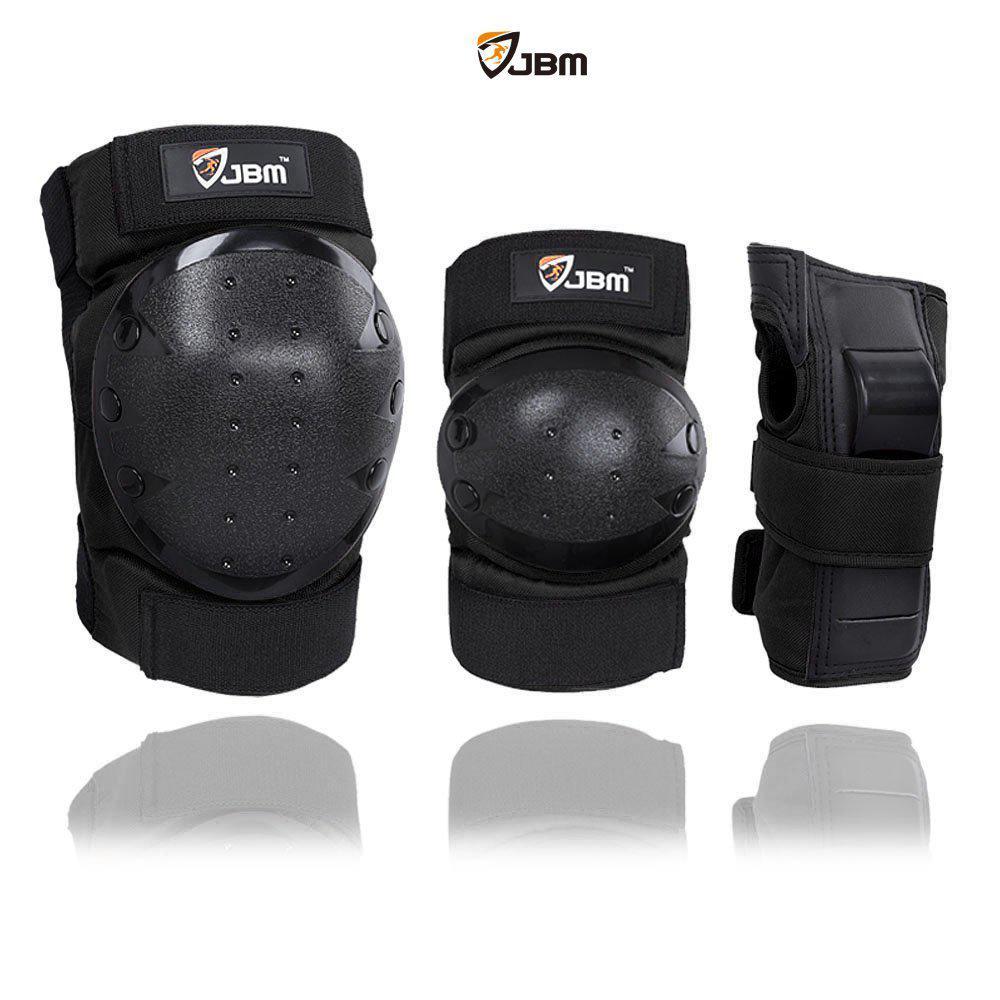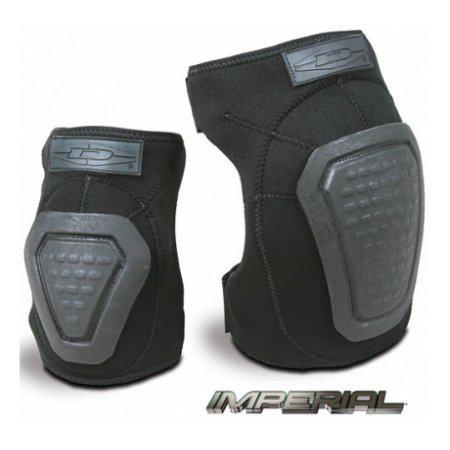The first image is the image on the left, the second image is the image on the right. For the images displayed, is the sentence "In both images, there are three different types of knee pads in a row." factually correct? Answer yes or no. No. The first image is the image on the left, the second image is the image on the right. Examine the images to the left and right. Is the description "The image on the right has 3 objects arranged from smallest to largest." accurate? Answer yes or no. No. 